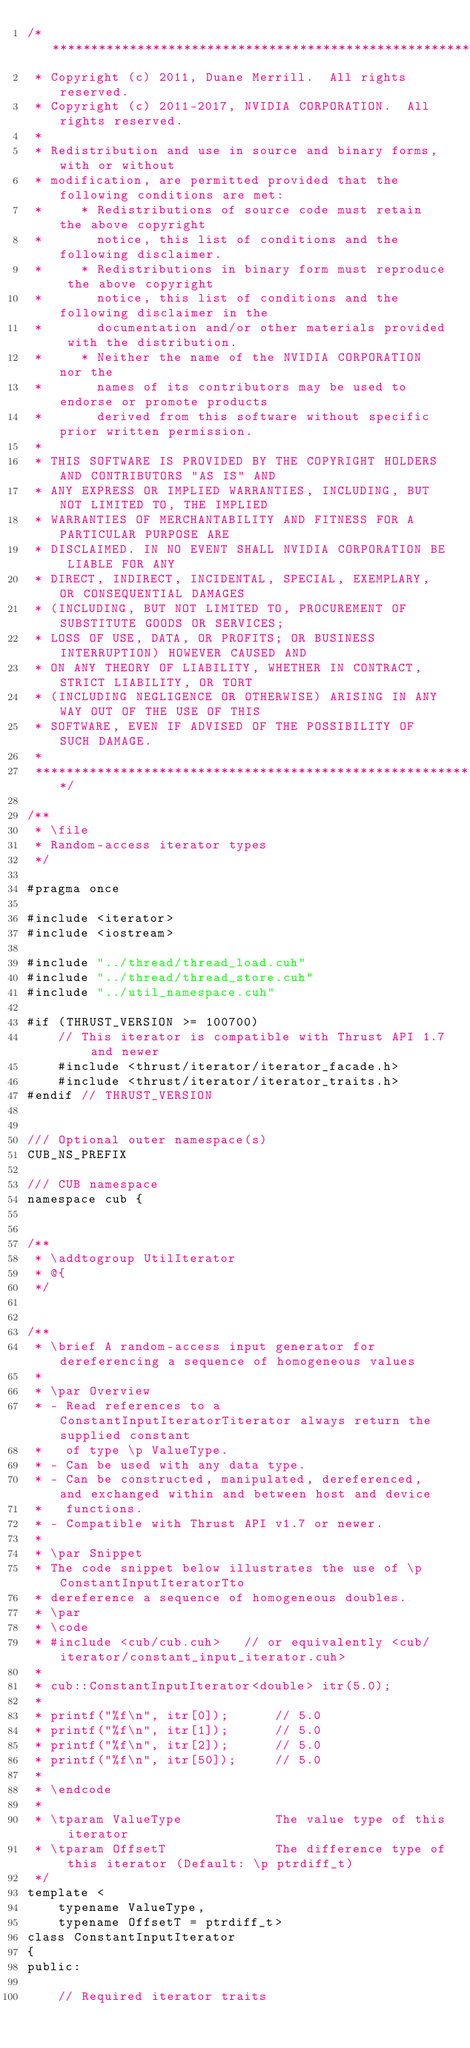<code> <loc_0><loc_0><loc_500><loc_500><_Cuda_>/******************************************************************************
 * Copyright (c) 2011, Duane Merrill.  All rights reserved.
 * Copyright (c) 2011-2017, NVIDIA CORPORATION.  All rights reserved.
 * 
 * Redistribution and use in source and binary forms, with or without
 * modification, are permitted provided that the following conditions are met:
 *     * Redistributions of source code must retain the above copyright
 *       notice, this list of conditions and the following disclaimer.
 *     * Redistributions in binary form must reproduce the above copyright
 *       notice, this list of conditions and the following disclaimer in the
 *       documentation and/or other materials provided with the distribution.
 *     * Neither the name of the NVIDIA CORPORATION nor the
 *       names of its contributors may be used to endorse or promote products
 *       derived from this software without specific prior written permission.
 * 
 * THIS SOFTWARE IS PROVIDED BY THE COPYRIGHT HOLDERS AND CONTRIBUTORS "AS IS" AND
 * ANY EXPRESS OR IMPLIED WARRANTIES, INCLUDING, BUT NOT LIMITED TO, THE IMPLIED
 * WARRANTIES OF MERCHANTABILITY AND FITNESS FOR A PARTICULAR PURPOSE ARE
 * DISCLAIMED. IN NO EVENT SHALL NVIDIA CORPORATION BE LIABLE FOR ANY
 * DIRECT, INDIRECT, INCIDENTAL, SPECIAL, EXEMPLARY, OR CONSEQUENTIAL DAMAGES
 * (INCLUDING, BUT NOT LIMITED TO, PROCUREMENT OF SUBSTITUTE GOODS OR SERVICES;
 * LOSS OF USE, DATA, OR PROFITS; OR BUSINESS INTERRUPTION) HOWEVER CAUSED AND
 * ON ANY THEORY OF LIABILITY, WHETHER IN CONTRACT, STRICT LIABILITY, OR TORT
 * (INCLUDING NEGLIGENCE OR OTHERWISE) ARISING IN ANY WAY OUT OF THE USE OF THIS
 * SOFTWARE, EVEN IF ADVISED OF THE POSSIBILITY OF SUCH DAMAGE.
 *
 ******************************************************************************/

/**
 * \file
 * Random-access iterator types
 */

#pragma once

#include <iterator>
#include <iostream>

#include "../thread/thread_load.cuh"
#include "../thread/thread_store.cuh"
#include "../util_namespace.cuh"

#if (THRUST_VERSION >= 100700)
    // This iterator is compatible with Thrust API 1.7 and newer
    #include <thrust/iterator/iterator_facade.h>
    #include <thrust/iterator/iterator_traits.h>
#endif // THRUST_VERSION


/// Optional outer namespace(s)
CUB_NS_PREFIX

/// CUB namespace
namespace cub {


/**
 * \addtogroup UtilIterator
 * @{
 */


/**
 * \brief A random-access input generator for dereferencing a sequence of homogeneous values
 *
 * \par Overview
 * - Read references to a ConstantInputIteratorTiterator always return the supplied constant
 *   of type \p ValueType.
 * - Can be used with any data type.
 * - Can be constructed, manipulated, dereferenced, and exchanged within and between host and device
 *   functions.
 * - Compatible with Thrust API v1.7 or newer.
 *
 * \par Snippet
 * The code snippet below illustrates the use of \p ConstantInputIteratorTto
 * dereference a sequence of homogeneous doubles.
 * \par
 * \code
 * #include <cub/cub.cuh>   // or equivalently <cub/iterator/constant_input_iterator.cuh>
 *
 * cub::ConstantInputIterator<double> itr(5.0);
 *
 * printf("%f\n", itr[0]);      // 5.0
 * printf("%f\n", itr[1]);      // 5.0
 * printf("%f\n", itr[2]);      // 5.0
 * printf("%f\n", itr[50]);     // 5.0
 *
 * \endcode
 *
 * \tparam ValueType            The value type of this iterator
 * \tparam OffsetT              The difference type of this iterator (Default: \p ptrdiff_t)
 */
template <
    typename ValueType,
    typename OffsetT = ptrdiff_t>
class ConstantInputIterator
{
public:

    // Required iterator traits</code> 